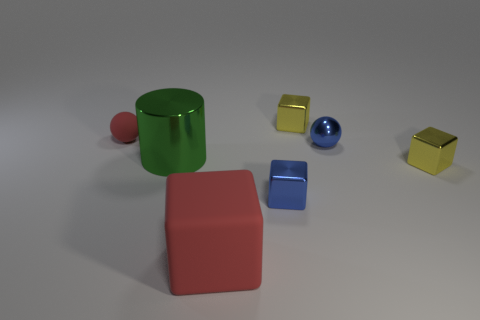How many other objects are there of the same size as the red matte sphere?
Make the answer very short. 4. How many blue metallic objects are there?
Your response must be concise. 2. Is the red ball the same size as the shiny ball?
Your answer should be compact. Yes. What number of other things are the same shape as the small red matte object?
Your response must be concise. 1. What is the material of the sphere to the left of the green shiny cylinder in front of the tiny red matte thing?
Your response must be concise. Rubber. Are there any tiny blue things in front of the large green metallic object?
Offer a very short reply. Yes. Does the blue metal ball have the same size as the red matte thing that is to the left of the large red rubber thing?
Make the answer very short. Yes. The blue metallic thing that is the same shape as the large red rubber thing is what size?
Your response must be concise. Small. There is a red rubber object that is behind the matte block; does it have the same size as the rubber thing that is in front of the tiny matte sphere?
Provide a short and direct response. No. How many tiny things are red spheres or metallic cubes?
Offer a very short reply. 4. 